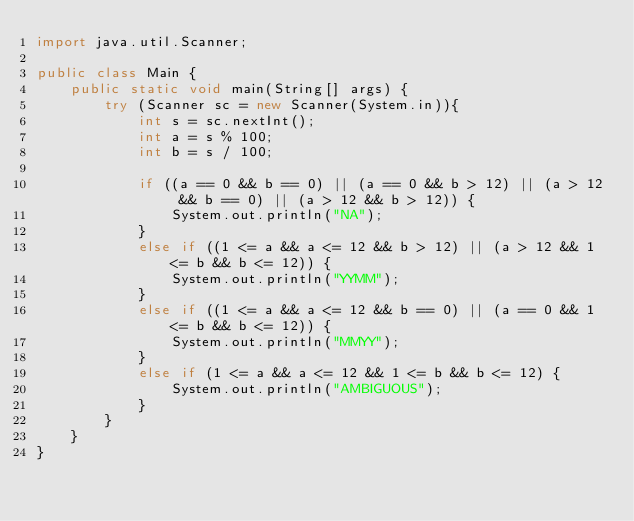<code> <loc_0><loc_0><loc_500><loc_500><_Java_>import java.util.Scanner;

public class Main {
	public static void main(String[] args) {		
		try (Scanner sc = new Scanner(System.in)){
			int s = sc.nextInt();
			int a = s % 100;
			int b = s / 100;
			
			if ((a == 0 && b == 0) || (a == 0 && b > 12) || (a > 12 && b == 0) || (a > 12 && b > 12)) {
				System.out.println("NA");
			}
			else if ((1 <= a && a <= 12 && b > 12) || (a > 12 && 1 <= b && b <= 12)) {
				System.out.println("YYMM");
			}
			else if ((1 <= a && a <= 12 && b == 0) || (a == 0 && 1 <= b && b <= 12)) {
				System.out.println("MMYY");
			}
			else if (1 <= a && a <= 12 && 1 <= b && b <= 12) {
				System.out.println("AMBIGUOUS");
			}
		}
	}
}
</code> 